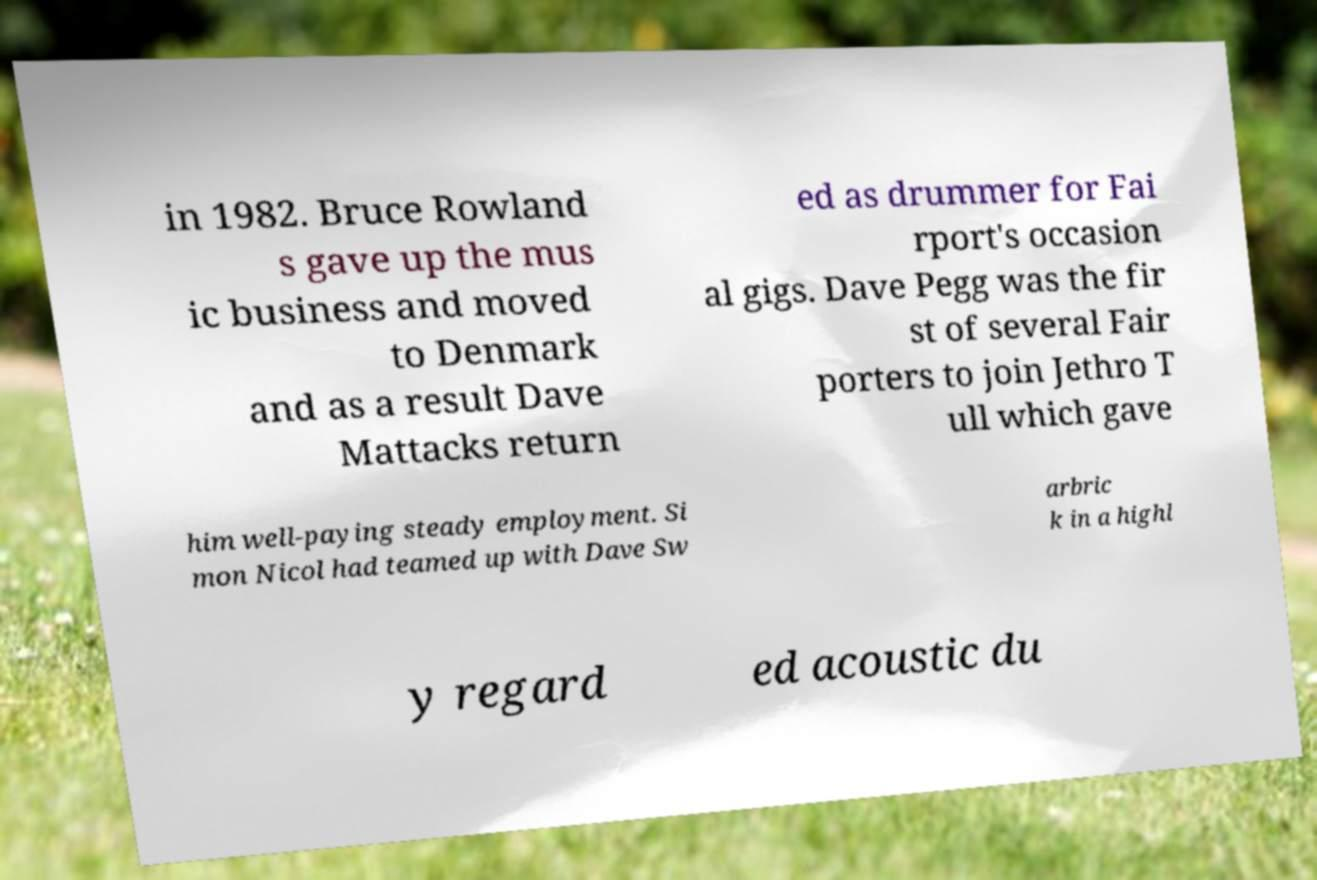I need the written content from this picture converted into text. Can you do that? in 1982. Bruce Rowland s gave up the mus ic business and moved to Denmark and as a result Dave Mattacks return ed as drummer for Fai rport's occasion al gigs. Dave Pegg was the fir st of several Fair porters to join Jethro T ull which gave him well-paying steady employment. Si mon Nicol had teamed up with Dave Sw arbric k in a highl y regard ed acoustic du 